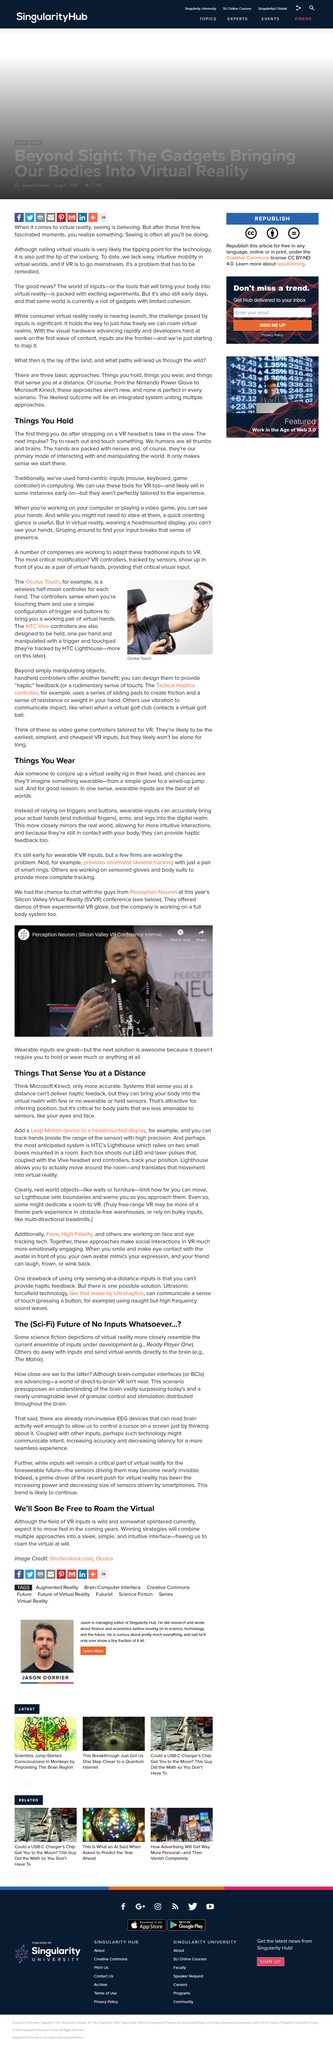Indicate a few pertinent items in this graphic. Haptic feedback cannot be delivered by systems that sense a person at a distance. I propose the creation of a virtual reality ring that can transport individuals into a fully immersive, computer-generated world. Some science fiction depictions of virtual reality depict a world where inputs are done away with. The hands are packed with nerves. The most anticipated system is HTC's Lighthouse, which utilizes two small boxes mounted in a room to track the position of the Vive headset and controllers using LED and laser pulses. 